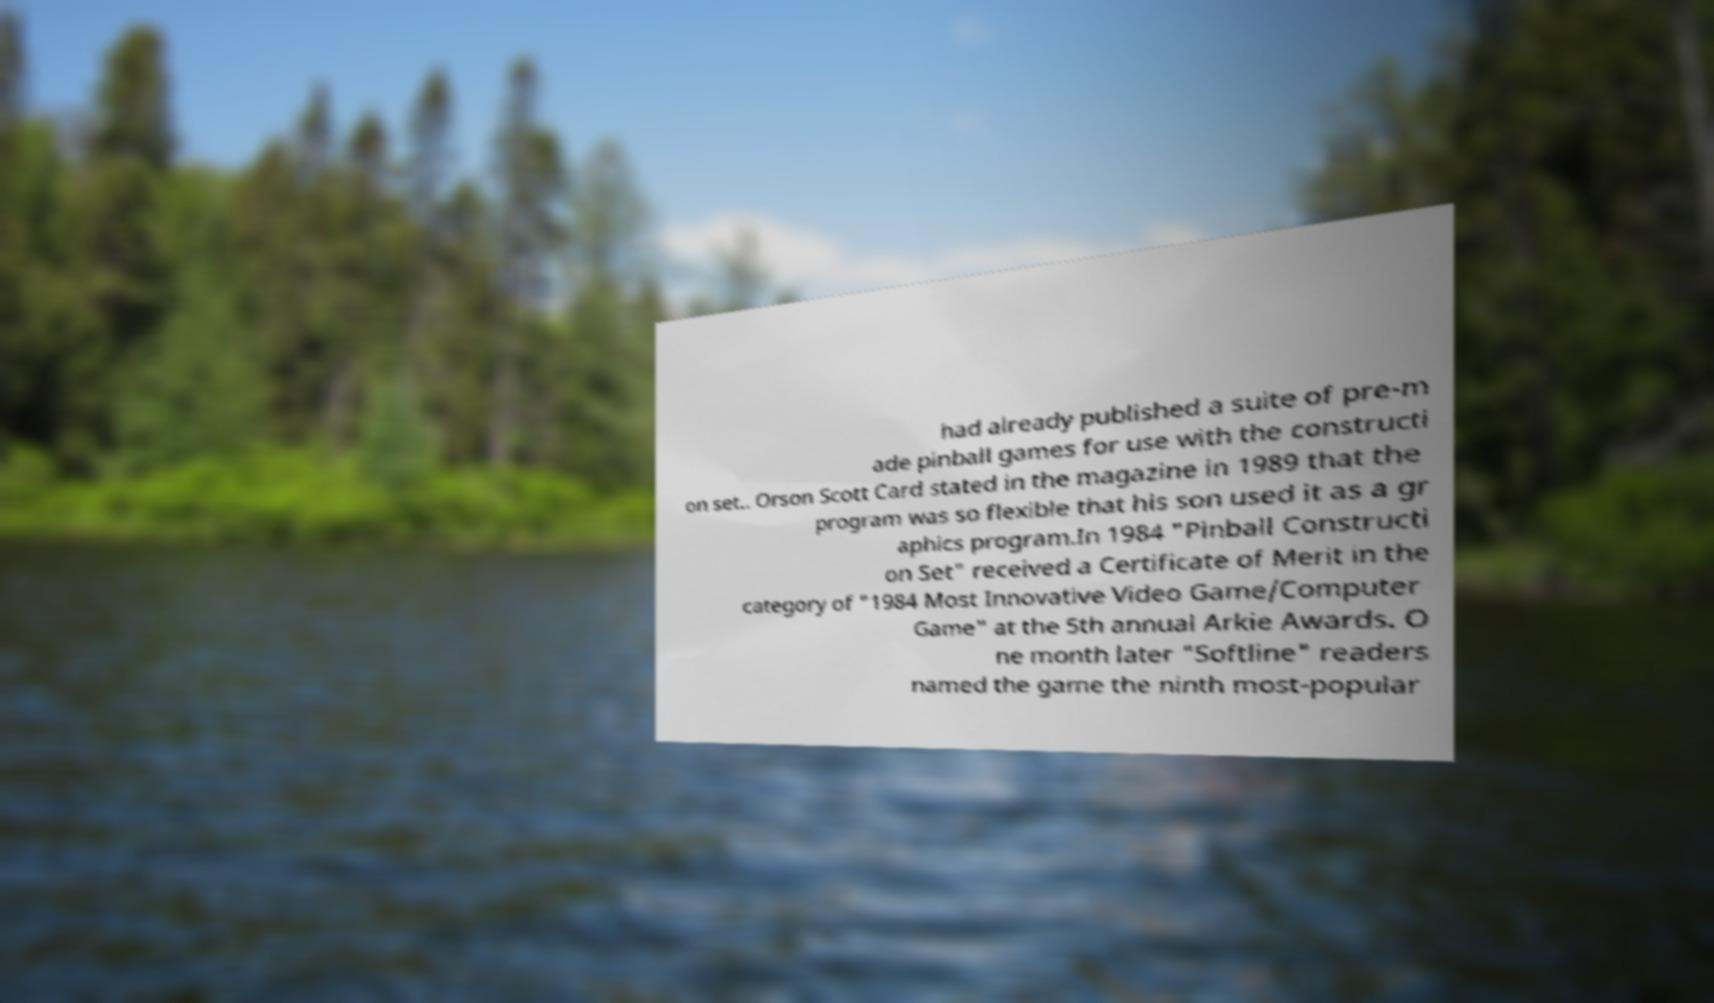Please identify and transcribe the text found in this image. had already published a suite of pre-m ade pinball games for use with the constructi on set.. Orson Scott Card stated in the magazine in 1989 that the program was so flexible that his son used it as a gr aphics program.In 1984 "Pinball Constructi on Set" received a Certificate of Merit in the category of "1984 Most Innovative Video Game/Computer Game" at the 5th annual Arkie Awards. O ne month later "Softline" readers named the game the ninth most-popular 